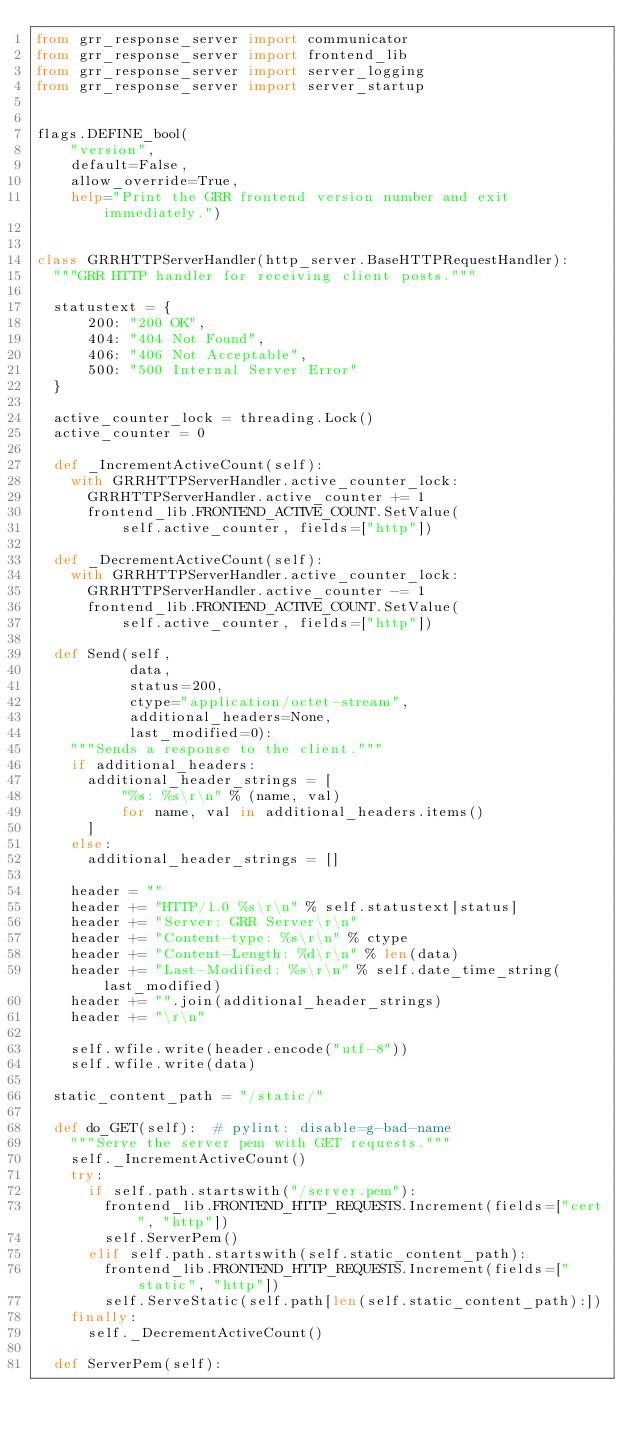Convert code to text. <code><loc_0><loc_0><loc_500><loc_500><_Python_>from grr_response_server import communicator
from grr_response_server import frontend_lib
from grr_response_server import server_logging
from grr_response_server import server_startup


flags.DEFINE_bool(
    "version",
    default=False,
    allow_override=True,
    help="Print the GRR frontend version number and exit immediately.")


class GRRHTTPServerHandler(http_server.BaseHTTPRequestHandler):
  """GRR HTTP handler for receiving client posts."""

  statustext = {
      200: "200 OK",
      404: "404 Not Found",
      406: "406 Not Acceptable",
      500: "500 Internal Server Error"
  }

  active_counter_lock = threading.Lock()
  active_counter = 0

  def _IncrementActiveCount(self):
    with GRRHTTPServerHandler.active_counter_lock:
      GRRHTTPServerHandler.active_counter += 1
      frontend_lib.FRONTEND_ACTIVE_COUNT.SetValue(
          self.active_counter, fields=["http"])

  def _DecrementActiveCount(self):
    with GRRHTTPServerHandler.active_counter_lock:
      GRRHTTPServerHandler.active_counter -= 1
      frontend_lib.FRONTEND_ACTIVE_COUNT.SetValue(
          self.active_counter, fields=["http"])

  def Send(self,
           data,
           status=200,
           ctype="application/octet-stream",
           additional_headers=None,
           last_modified=0):
    """Sends a response to the client."""
    if additional_headers:
      additional_header_strings = [
          "%s: %s\r\n" % (name, val)
          for name, val in additional_headers.items()
      ]
    else:
      additional_header_strings = []

    header = ""
    header += "HTTP/1.0 %s\r\n" % self.statustext[status]
    header += "Server: GRR Server\r\n"
    header += "Content-type: %s\r\n" % ctype
    header += "Content-Length: %d\r\n" % len(data)
    header += "Last-Modified: %s\r\n" % self.date_time_string(last_modified)
    header += "".join(additional_header_strings)
    header += "\r\n"

    self.wfile.write(header.encode("utf-8"))
    self.wfile.write(data)

  static_content_path = "/static/"

  def do_GET(self):  # pylint: disable=g-bad-name
    """Serve the server pem with GET requests."""
    self._IncrementActiveCount()
    try:
      if self.path.startswith("/server.pem"):
        frontend_lib.FRONTEND_HTTP_REQUESTS.Increment(fields=["cert", "http"])
        self.ServerPem()
      elif self.path.startswith(self.static_content_path):
        frontend_lib.FRONTEND_HTTP_REQUESTS.Increment(fields=["static", "http"])
        self.ServeStatic(self.path[len(self.static_content_path):])
    finally:
      self._DecrementActiveCount()

  def ServerPem(self):</code> 